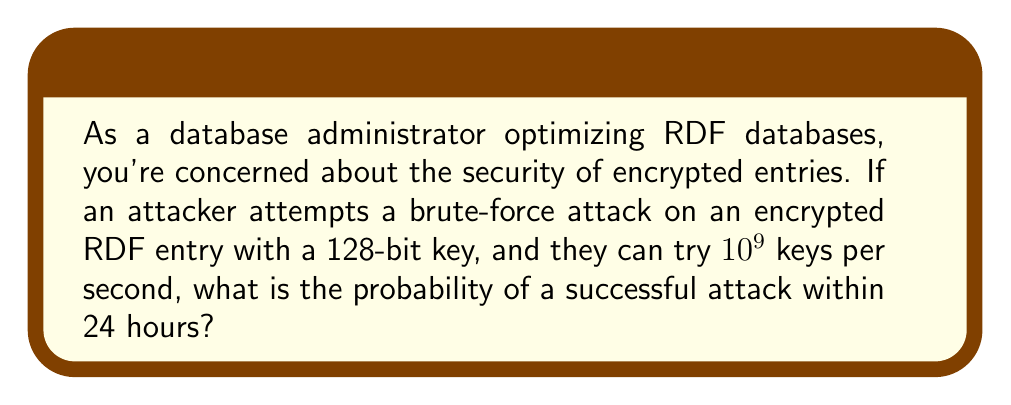Give your solution to this math problem. Let's approach this step-by-step:

1) First, we need to calculate the total number of possible keys:
   $$ \text{Total keys} = 2^{128} $$

2) Next, let's calculate how many keys can be tried in 24 hours:
   $$ \text{Keys per second} = 10^9 $$
   $$ \text{Seconds in 24 hours} = 24 \times 60 \times 60 = 86,400 $$
   $$ \text{Keys tried in 24 hours} = 10^9 \times 86,400 = 8.64 \times 10^{13} $$

3) The probability of success is the number of keys tried divided by the total number of possible keys:
   $$ P(\text{success}) = \frac{\text{Keys tried}}{\text{Total keys}} = \frac{8.64 \times 10^{13}}{2^{128}} $$

4) Let's calculate this:
   $$ P(\text{success}) = \frac{8.64 \times 10^{13}}{3.4028237 \times 10^{38}} \approx 2.54 \times 10^{-25} $$

This probability is extremely small, indicating that a brute-force attack on a 128-bit key within 24 hours is practically impossible.
Answer: $2.54 \times 10^{-25}$ 